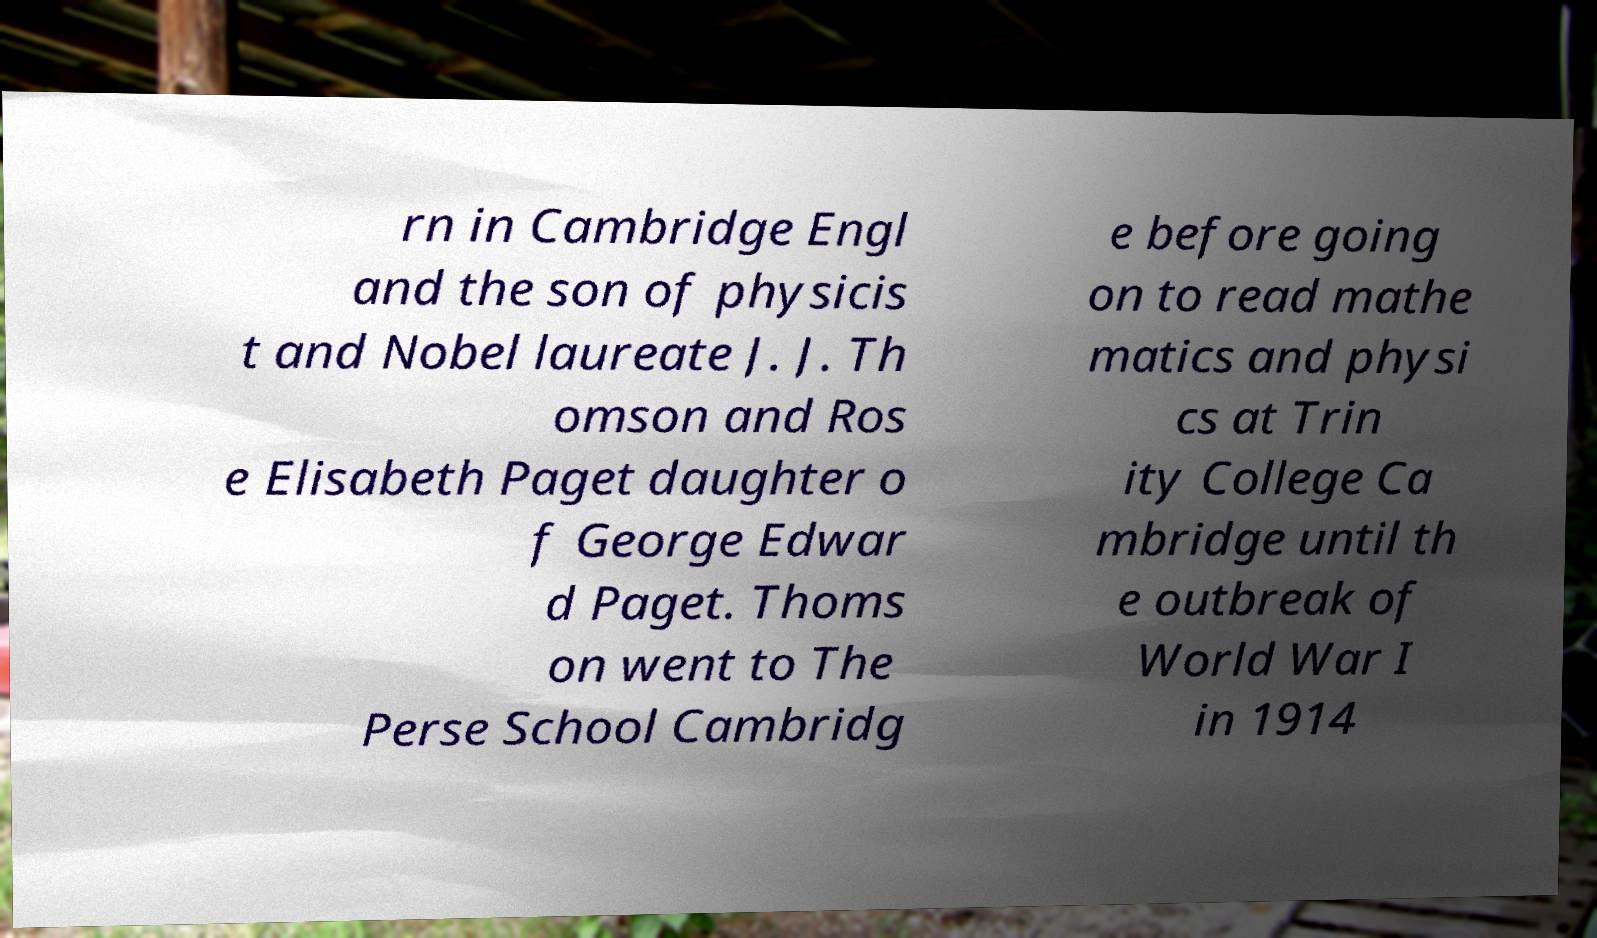There's text embedded in this image that I need extracted. Can you transcribe it verbatim? rn in Cambridge Engl and the son of physicis t and Nobel laureate J. J. Th omson and Ros e Elisabeth Paget daughter o f George Edwar d Paget. Thoms on went to The Perse School Cambridg e before going on to read mathe matics and physi cs at Trin ity College Ca mbridge until th e outbreak of World War I in 1914 